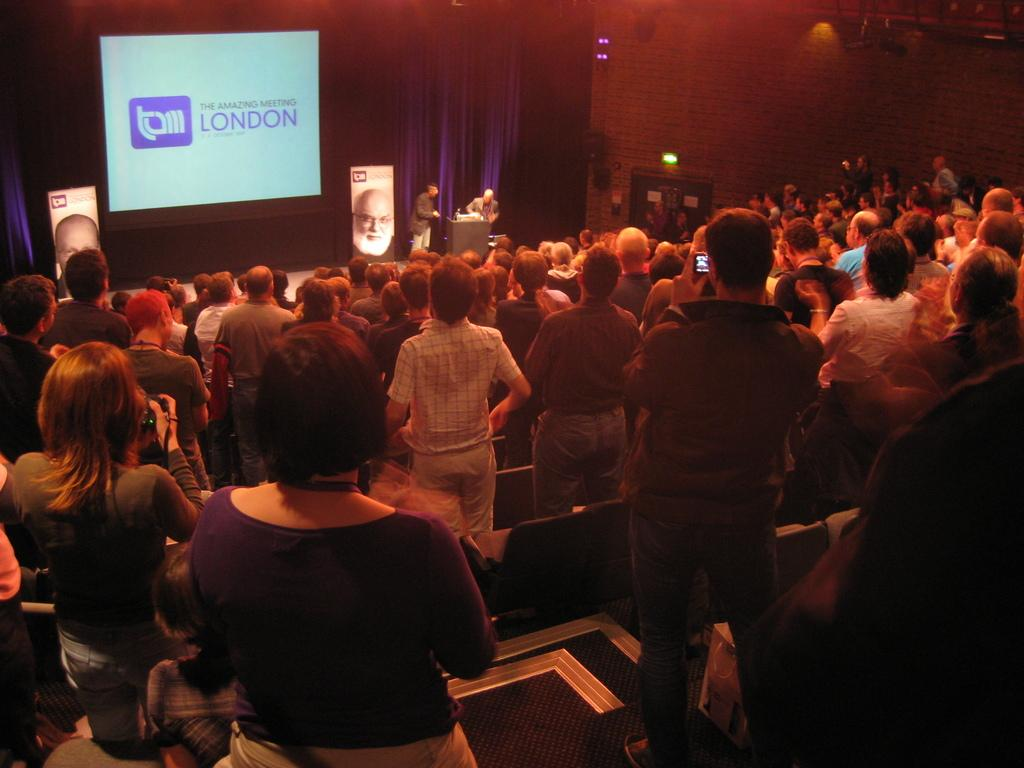What is the main subject of the image? The main subject of the image is a crowd. Can you describe any specific features or objects in the image? Yes, there is a screen in the top left of the image, a podium in the middle of the image, and a wall in the top right of the image. How many robins can be seen perched on the wall in the image? There are no robins present in the image; the wall only contains a screen and a podium. 